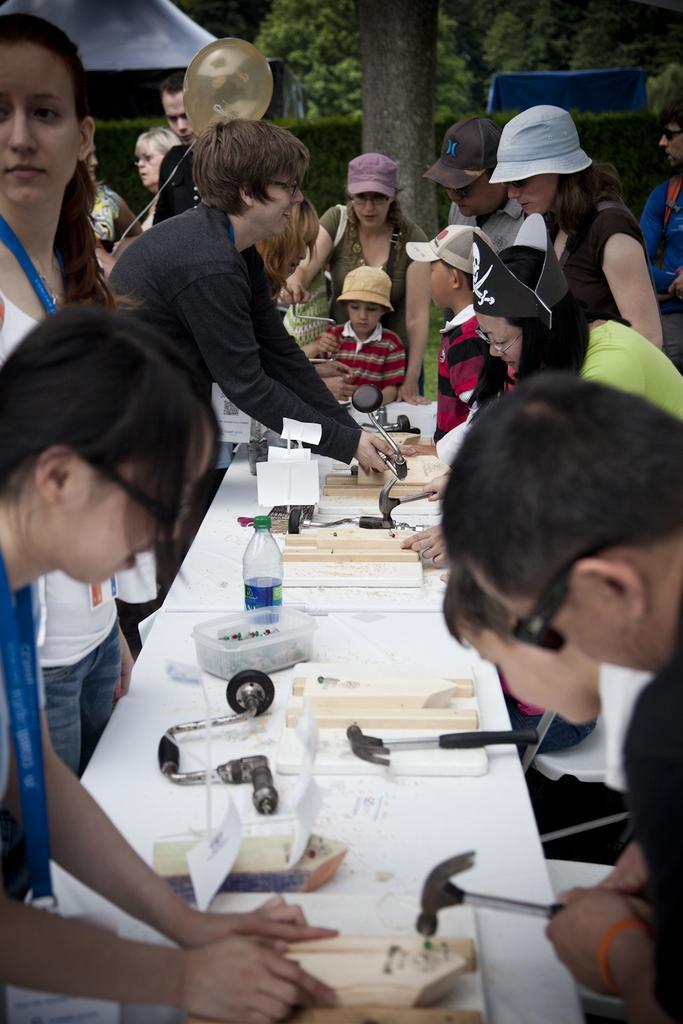Describe this image in one or two sentences. In this image there are group of people standing near the table there are hammer, wooden frames, bottle, box, and some items in the table ,and at the back ground there are group of people standing , tree, tent. 